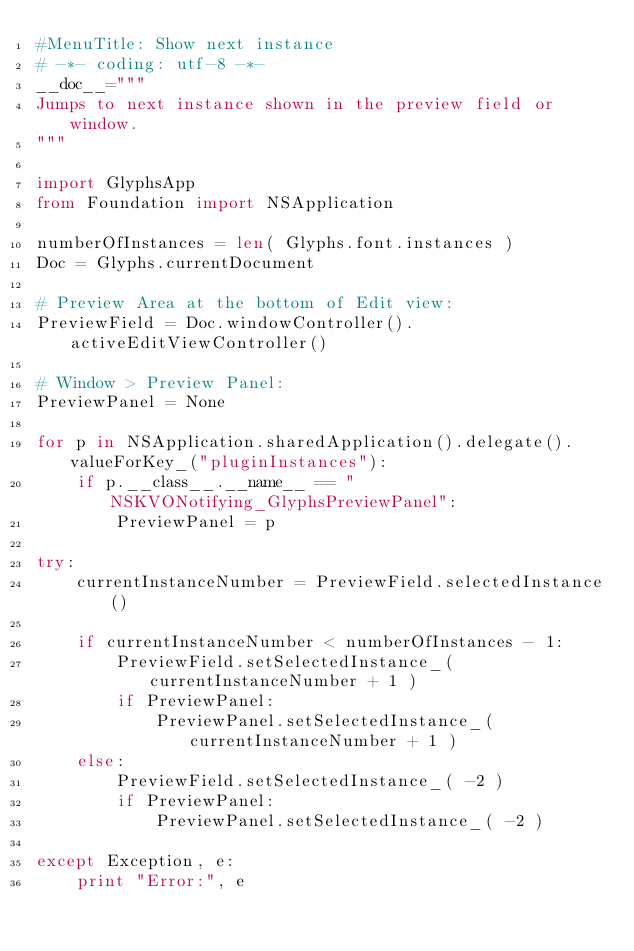<code> <loc_0><loc_0><loc_500><loc_500><_Python_>#MenuTitle: Show next instance
# -*- coding: utf-8 -*-
__doc__="""
Jumps to next instance shown in the preview field or window.
"""

import GlyphsApp
from Foundation import NSApplication

numberOfInstances = len( Glyphs.font.instances )
Doc = Glyphs.currentDocument

# Preview Area at the bottom of Edit view:
PreviewField = Doc.windowController().activeEditViewController()

# Window > Preview Panel:
PreviewPanel = None

for p in NSApplication.sharedApplication().delegate().valueForKey_("pluginInstances"):
	if p.__class__.__name__ == "NSKVONotifying_GlyphsPreviewPanel":
		PreviewPanel = p

try:
	currentInstanceNumber = PreviewField.selectedInstance()

	if currentInstanceNumber < numberOfInstances - 1:
		PreviewField.setSelectedInstance_( currentInstanceNumber + 1 )
		if PreviewPanel:
			PreviewPanel.setSelectedInstance_( currentInstanceNumber + 1 )
	else:
		PreviewField.setSelectedInstance_( -2 )
		if PreviewPanel:
			PreviewPanel.setSelectedInstance_( -2 )

except Exception, e:
	print "Error:", e
</code> 